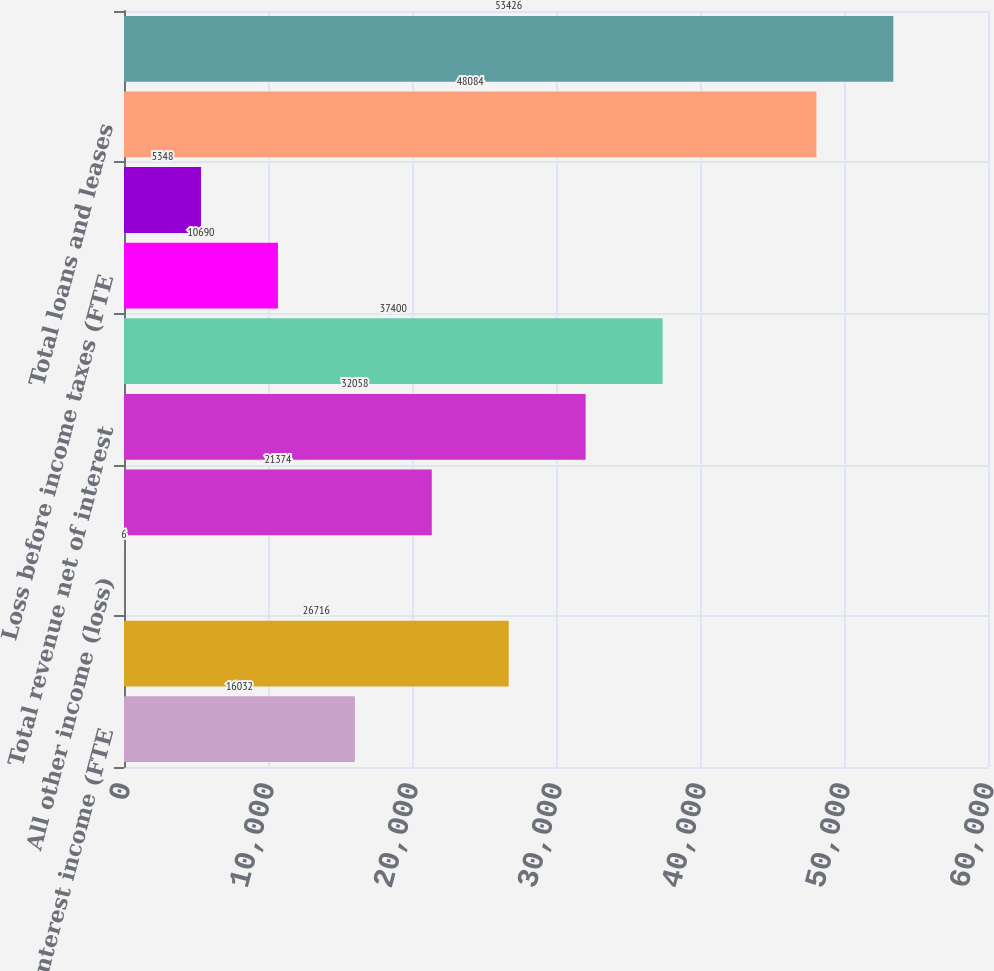<chart> <loc_0><loc_0><loc_500><loc_500><bar_chart><fcel>Net interest income (FTE<fcel>Mortgage banking income<fcel>All other income (loss)<fcel>Total noninterest income<fcel>Total revenue net of interest<fcel>Noninterest expense<fcel>Loss before income taxes (FTE<fcel>Income tax benefit (FTE basis)<fcel>Total loans and leases<fcel>Total earning assets<nl><fcel>16032<fcel>26716<fcel>6<fcel>21374<fcel>32058<fcel>37400<fcel>10690<fcel>5348<fcel>48084<fcel>53426<nl></chart> 